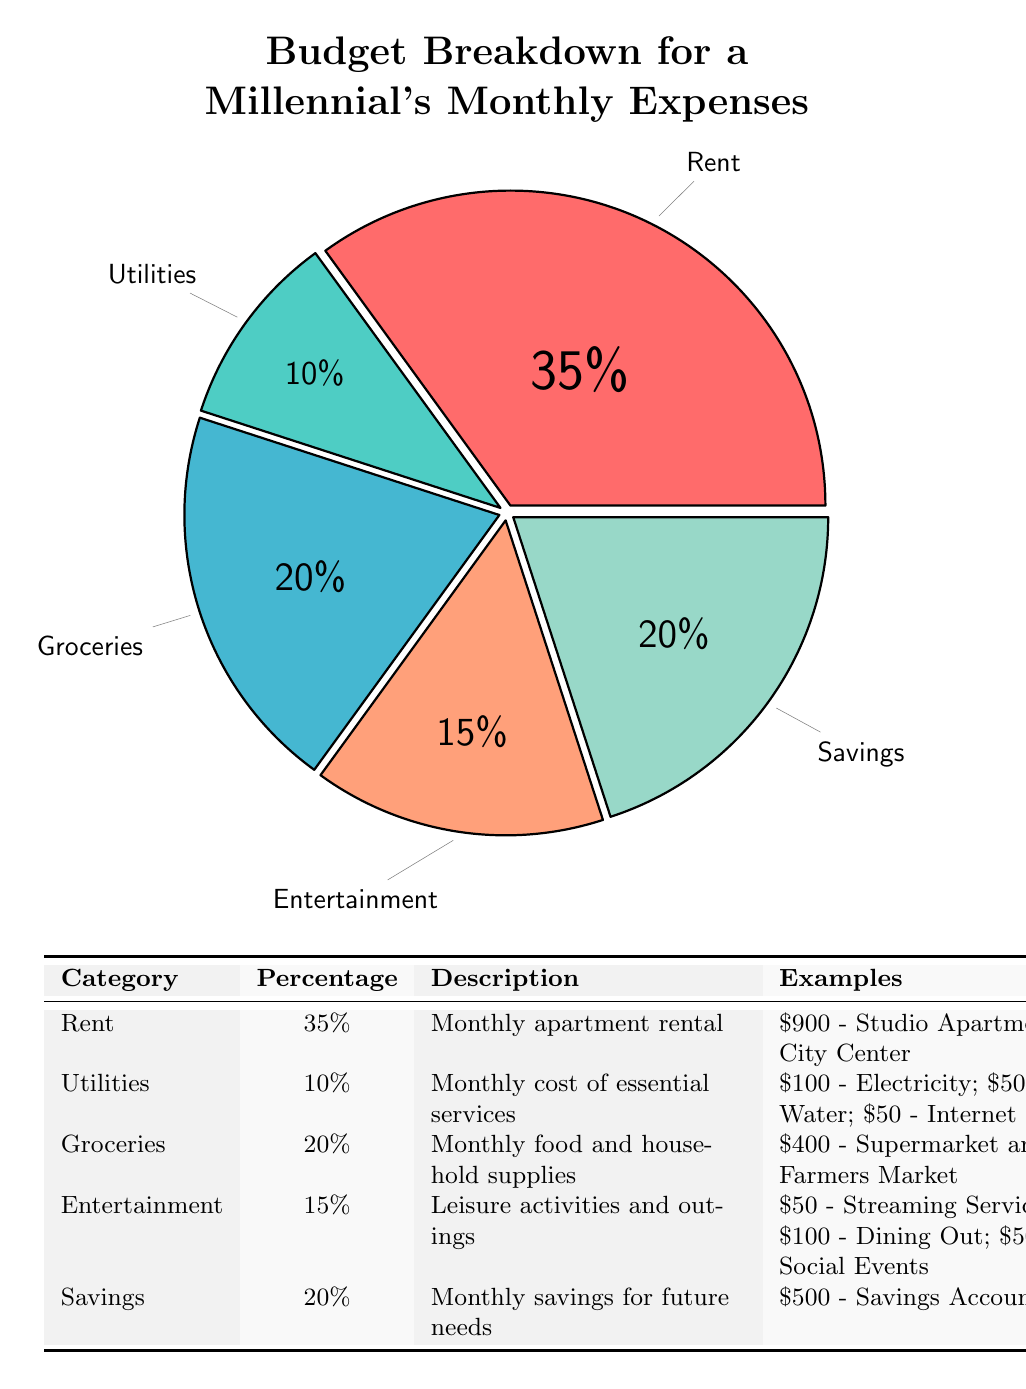What percentage of the budget is allocated to rent? The diagram indicates that rent occupies 35% of the budget, as shown directly in the pie chart and in the detailed table.
Answer: 35% What is the color representing utilities? The color representing utilities in the pie chart is a teal shade, marked by the utilitiescolor in the code, and confirmed by its placement in the pie chart legend.
Answer: Teal How many categories are included in the budget breakdown? The diagram presents five categories: Rent, Utilities, Groceries, Entertainment, and Savings, which can be counted from the table and pie chart.
Answer: 5 Which budget category has the highest percentage? Rent is the highest category at 35%, as indicated clearly in the pie chart and reiterated in the table's percentage column.
Answer: Rent What percentage is allocated to savings and entertainment combined? By adding their percentages, savings (20%) and entertainment (15%) combined contribute 35% to the budget. This calculation is done by straightforward addition of each category's share from the pie chart.
Answer: 35% What examples are provided for groceries? The detailed table lists $400 spent at supermarkets and farmer's markets as an example of groceries. This information can be found under the Examples column in the table associated with the Groceries category.
Answer: $400 - Supermarket and Farmers Market What is the total percentage of expenses allocated to utilities and entertainment? The total percentage can be calculated by adding the percentages of utilities (10%) and entertainment (15%), resulting in a combined total of 25%. This is derived from the respective sections in the pie chart and table.
Answer: 25% Which expense category has the lowest percentage? Utilities hold the lowest percentage at 10%, which is evident from both the pie chart and the detailed table summarizing all categories.
Answer: 10% What is the monthly cost of utilities as provided in the diagram? The diagram specifies the monthly cost of utilities as $100 for electricity, $50 for water, and $50 for internet, which together gives a detailed insight in the table.
Answer: $100 - Electricity; $50 - Water; $50 - Internet 